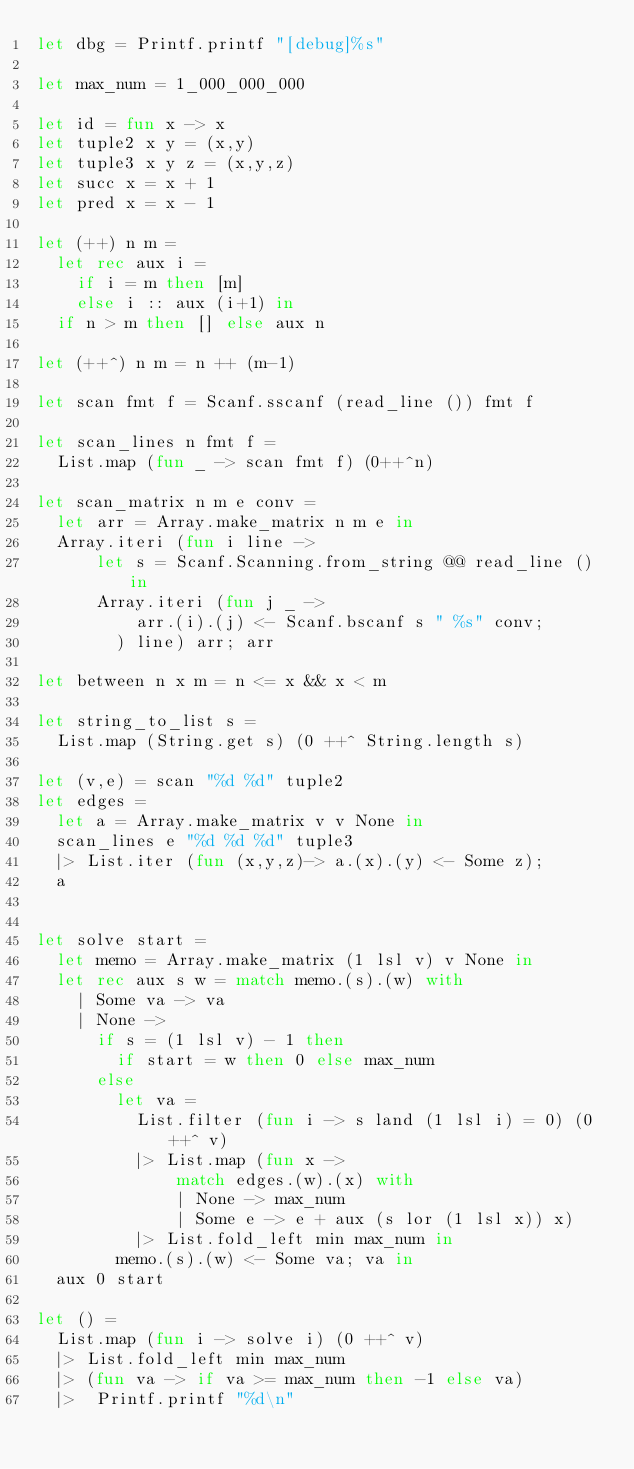Convert code to text. <code><loc_0><loc_0><loc_500><loc_500><_OCaml_>let dbg = Printf.printf "[debug]%s"

let max_num = 1_000_000_000

let id = fun x -> x
let tuple2 x y = (x,y)
let tuple3 x y z = (x,y,z)
let succ x = x + 1
let pred x = x - 1

let (++) n m =
  let rec aux i =
    if i = m then [m]
    else i :: aux (i+1) in
  if n > m then [] else aux n

let (++^) n m = n ++ (m-1)

let scan fmt f = Scanf.sscanf (read_line ()) fmt f

let scan_lines n fmt f =
  List.map (fun _ -> scan fmt f) (0++^n)

let scan_matrix n m e conv =
  let arr = Array.make_matrix n m e in
  Array.iteri (fun i line ->
      let s = Scanf.Scanning.from_string @@ read_line () in
      Array.iteri (fun j _ ->
          arr.(i).(j) <- Scanf.bscanf s " %s" conv;
        ) line) arr; arr

let between n x m = n <= x && x < m

let string_to_list s =
  List.map (String.get s) (0 ++^ String.length s)

let (v,e) = scan "%d %d" tuple2
let edges =
  let a = Array.make_matrix v v None in
  scan_lines e "%d %d %d" tuple3
  |> List.iter (fun (x,y,z)-> a.(x).(y) <- Some z);
  a


let solve start =
  let memo = Array.make_matrix (1 lsl v) v None in
  let rec aux s w = match memo.(s).(w) with
    | Some va -> va
    | None ->
      if s = (1 lsl v) - 1 then
        if start = w then 0 else max_num
      else
        let va =
          List.filter (fun i -> s land (1 lsl i) = 0) (0 ++^ v)
          |> List.map (fun x ->
              match edges.(w).(x) with
              | None -> max_num
              | Some e -> e + aux (s lor (1 lsl x)) x)
          |> List.fold_left min max_num in
        memo.(s).(w) <- Some va; va in
  aux 0 start

let () =
  List.map (fun i -> solve i) (0 ++^ v)
  |> List.fold_left min max_num
  |> (fun va -> if va >= max_num then -1 else va)
  |>  Printf.printf "%d\n"

</code> 